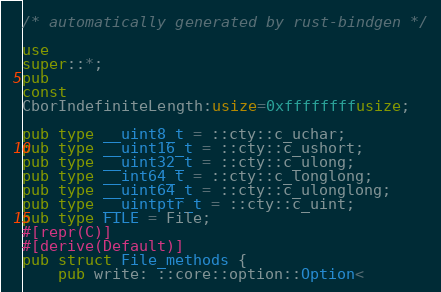<code> <loc_0><loc_0><loc_500><loc_500><_Rust_>/* automatically generated by rust-bindgen */

use
super::*;
pub
const
CborIndefiniteLength:usize=0xffffffffusize;

pub type __uint8_t = ::cty::c_uchar;
pub type __uint16_t = ::cty::c_ushort;
pub type __uint32_t = ::cty::c_ulong;
pub type __int64_t = ::cty::c_longlong;
pub type __uint64_t = ::cty::c_ulonglong;
pub type __uintptr_t = ::cty::c_uint;
pub type FILE = File;
#[repr(C)]
#[derive(Default)]
pub struct File_methods {
    pub write: ::core::option::Option<</code> 